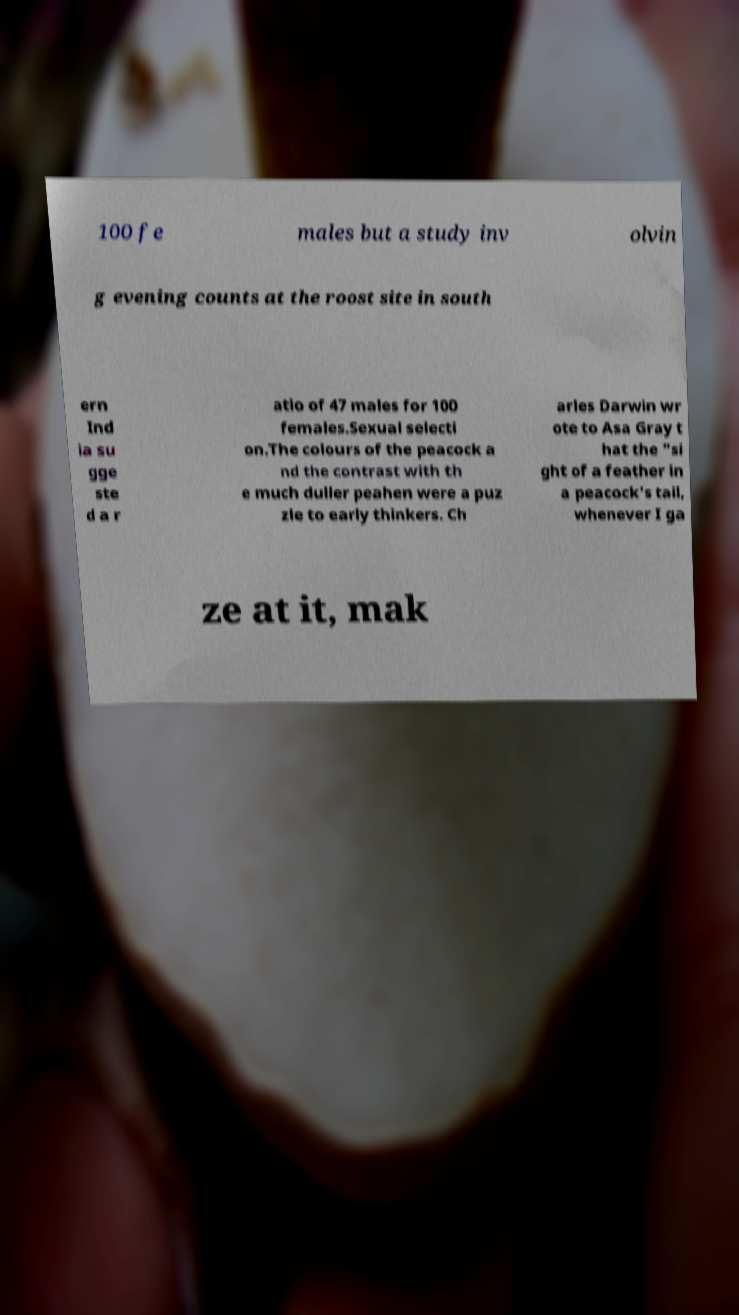Please identify and transcribe the text found in this image. 100 fe males but a study inv olvin g evening counts at the roost site in south ern Ind ia su gge ste d a r atio of 47 males for 100 females.Sexual selecti on.The colours of the peacock a nd the contrast with th e much duller peahen were a puz zle to early thinkers. Ch arles Darwin wr ote to Asa Gray t hat the "si ght of a feather in a peacock's tail, whenever I ga ze at it, mak 